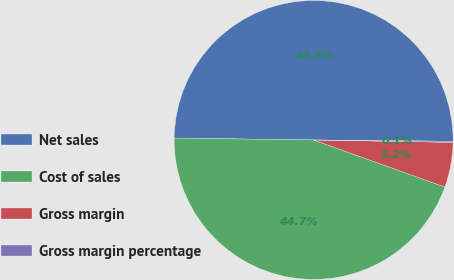<chart> <loc_0><loc_0><loc_500><loc_500><pie_chart><fcel>Net sales<fcel>Cost of sales<fcel>Gross margin<fcel>Gross margin percentage<nl><fcel>49.94%<fcel>44.74%<fcel>5.2%<fcel>0.13%<nl></chart> 